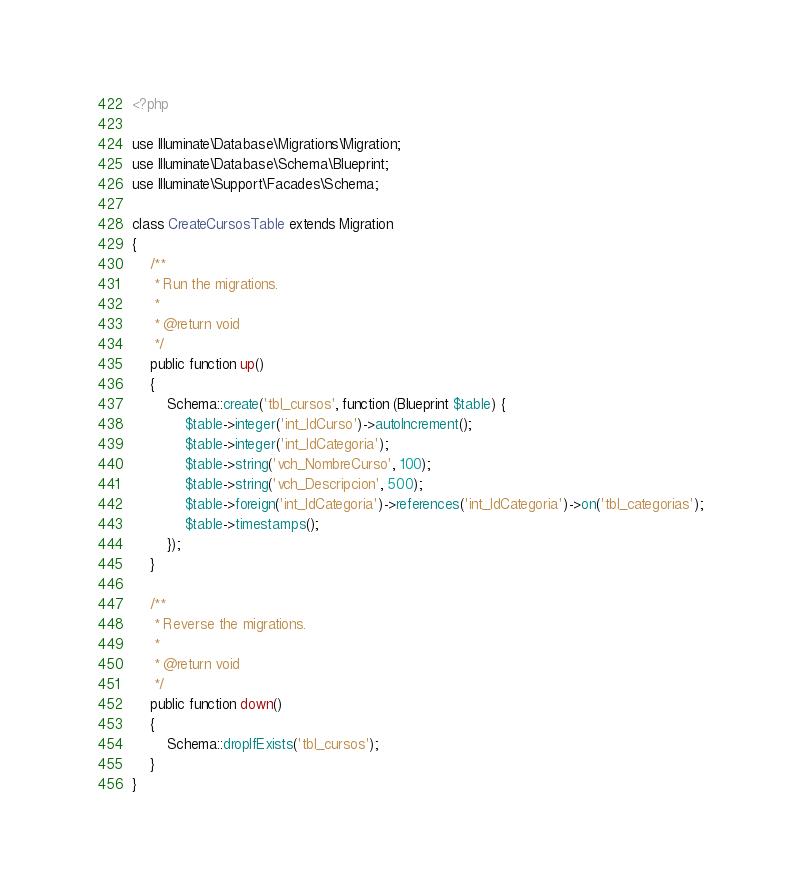<code> <loc_0><loc_0><loc_500><loc_500><_PHP_><?php

use Illuminate\Database\Migrations\Migration;
use Illuminate\Database\Schema\Blueprint;
use Illuminate\Support\Facades\Schema;

class CreateCursosTable extends Migration
{
    /**
     * Run the migrations.
     *
     * @return void
     */
    public function up()
    {
        Schema::create('tbl_cursos', function (Blueprint $table) {
            $table->integer('int_IdCurso')->autoIncrement();
            $table->integer('int_IdCategoria');
            $table->string('vch_NombreCurso', 100);
            $table->string('vch_Descripcion', 500);
            $table->foreign('int_IdCategoria')->references('int_IdCategoria')->on('tbl_categorias');
            $table->timestamps();
        });
    }

    /**
     * Reverse the migrations.
     *
     * @return void
     */
    public function down()
    {
        Schema::dropIfExists('tbl_cursos');
    }
}
</code> 